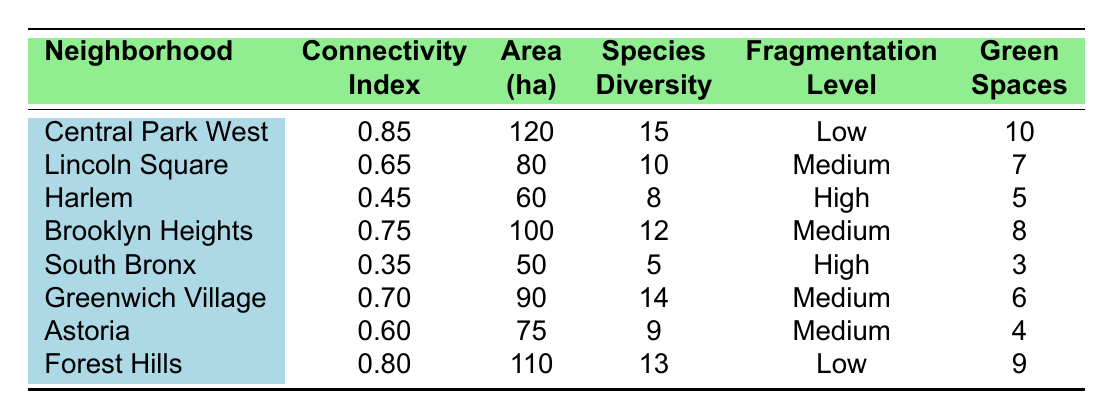What is the connectivity index of Central Park West? According to the table, the connectivity index for Central Park West is given directly as 0.85.
Answer: 0.85 Which neighborhood has the highest species diversity? By examining the species diversity column, Central Park West has the highest species diversity at 15.
Answer: Central Park West What is the area in hectares for Lincoln Square? The table shows that Lincoln Square has an area of 80 hectares.
Answer: 80 How many green spaces are there in the South Bronx? The table lists the number of green spaces in the South Bronx as 3.
Answer: 3 What is the average connectivity index of the neighborhoods listed? The connectivity indices of all neighborhoods are 0.85, 0.65, 0.45, 0.75, 0.35, 0.70, 0.60, and 0.80. Summing them gives 4.65, and dividing by 8 (the number of neighborhoods) results in an average of 0.58125, which we can round to 0.58.
Answer: 0.58 Is the fragmentation level in Forest Hills low? The table states that Forest Hills has a fragmentation level marked as "Low", confirming that is true.
Answer: Yes Which neighborhood has the lowest connectivity index? Looking at the connectivity indices, the South Bronx has the lowest at 0.35.
Answer: South Bronx Compare the area of Brooklyn Heights to that of Harlem. The area of Brooklyn Heights is 100 hectares and the area of Harlem is 60 hectares. The difference is calculated as 100 - 60 = 40 hectares, showing Brooklyn Heights has 40 more hectares.
Answer: 40 hectares Is there any neighborhood with a connectivity index above 0.70 that has a medium fragmentation level? The neighborhoods with a connectivity index above 0.70 are Central Park West (0.85), Brooklyn Heights (0.75), Greenwich Village (0.70), and Forest Hills (0.80). Among these, only Brooklyn Heights has a medium fragmentation level.
Answer: Yes, Brooklyn Heights If you sum the green space counts for all neighborhoods, what is the total? The number of green spaces are 10, 7, 5, 8, 3, 6, 4, and 9. Summing these gives 10 + 7 + 5 + 8 + 3 + 6 + 4 + 9 = 52.
Answer: 52 By how much does the connectivity index differ between Forest Hills and Harlem? The connectivity index for Forest Hills is 0.80 and for Harlem it is 0.45. The difference is 0.80 - 0.45 = 0.35.
Answer: 0.35 